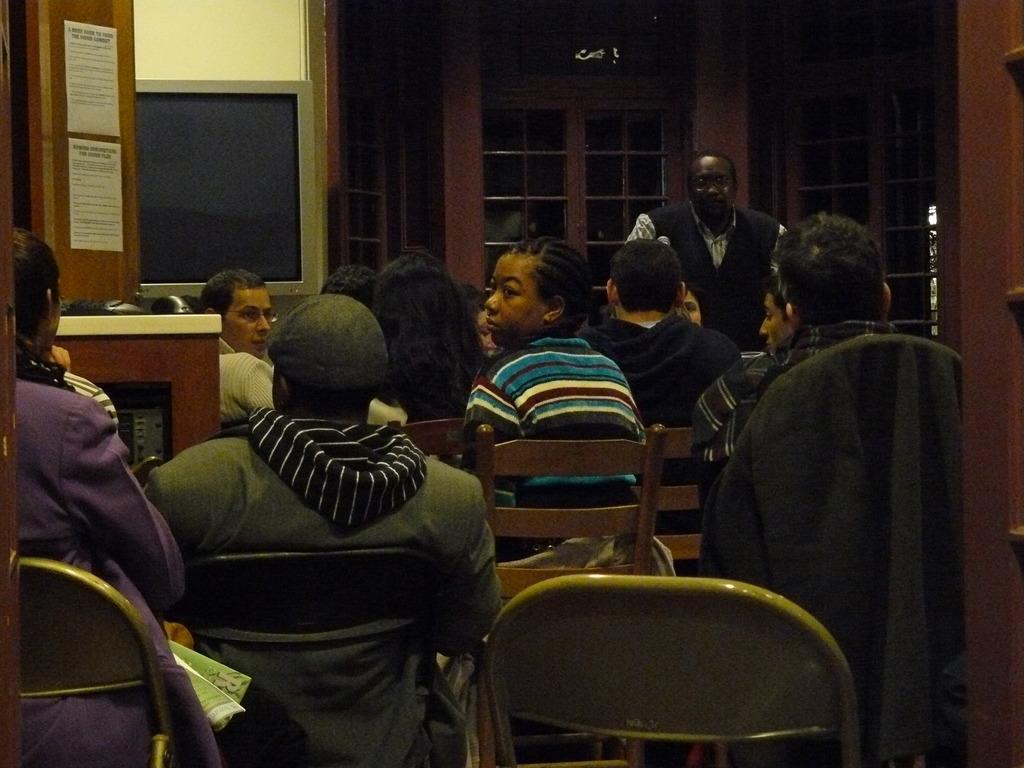Describe this image in one or two sentences. This image consists of some people who are sitting in chairs. There is a person who is standing in the middle. There are papers pasted on the left side top corner. 